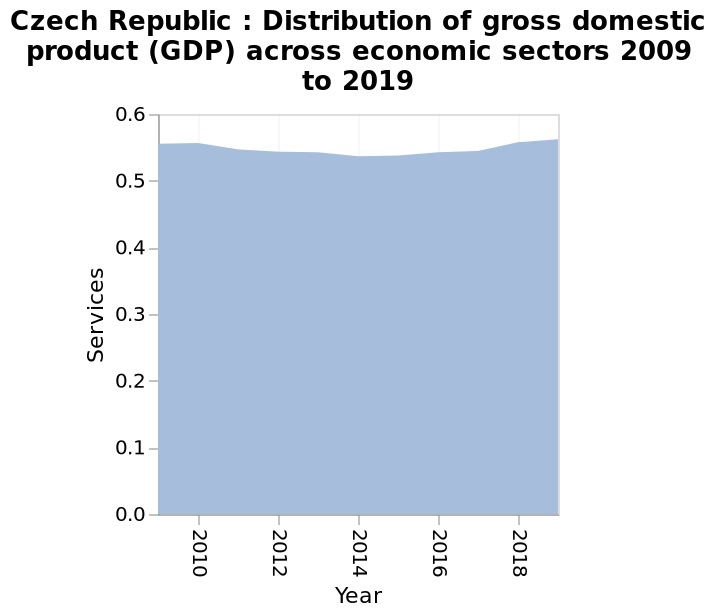<image>
What does the x-axis plot?  The x-axis plots Year. 